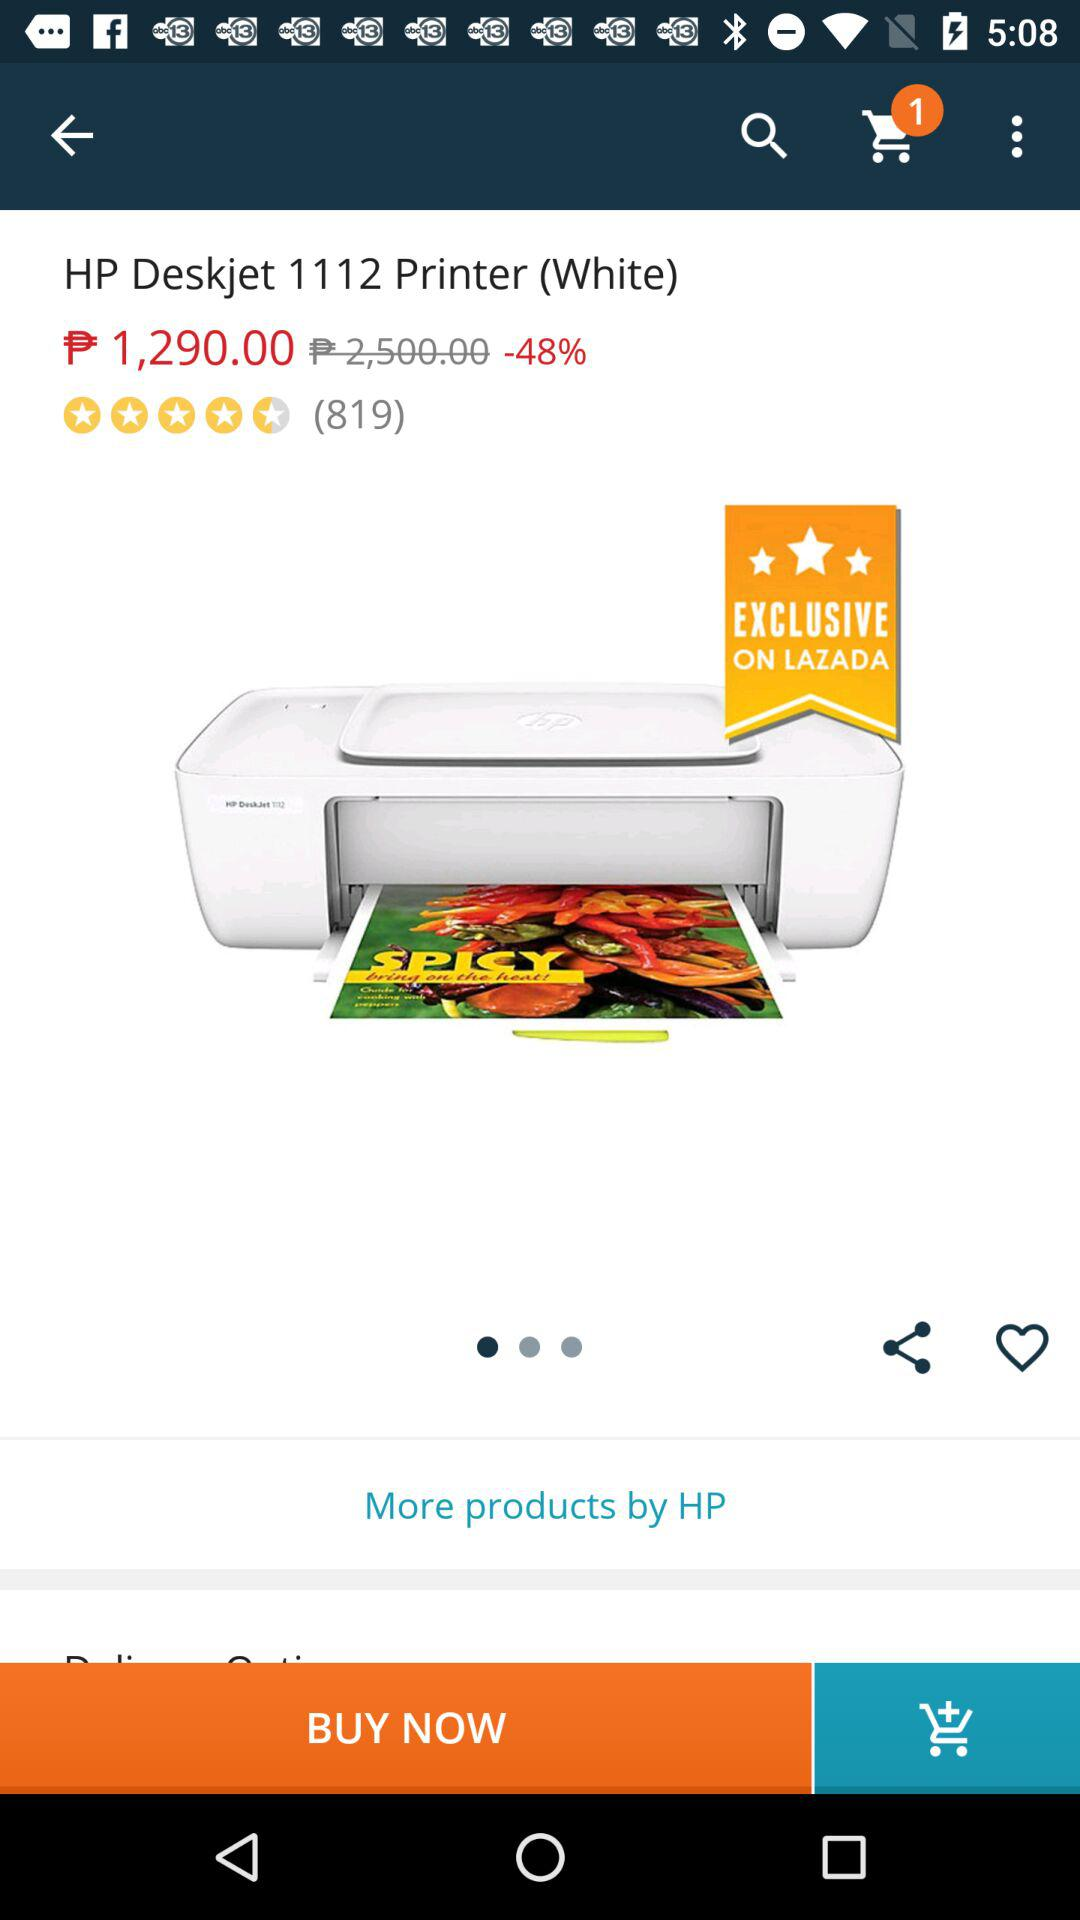What is the price of the printer? The price of the printer is ₱ 1,290.00. 